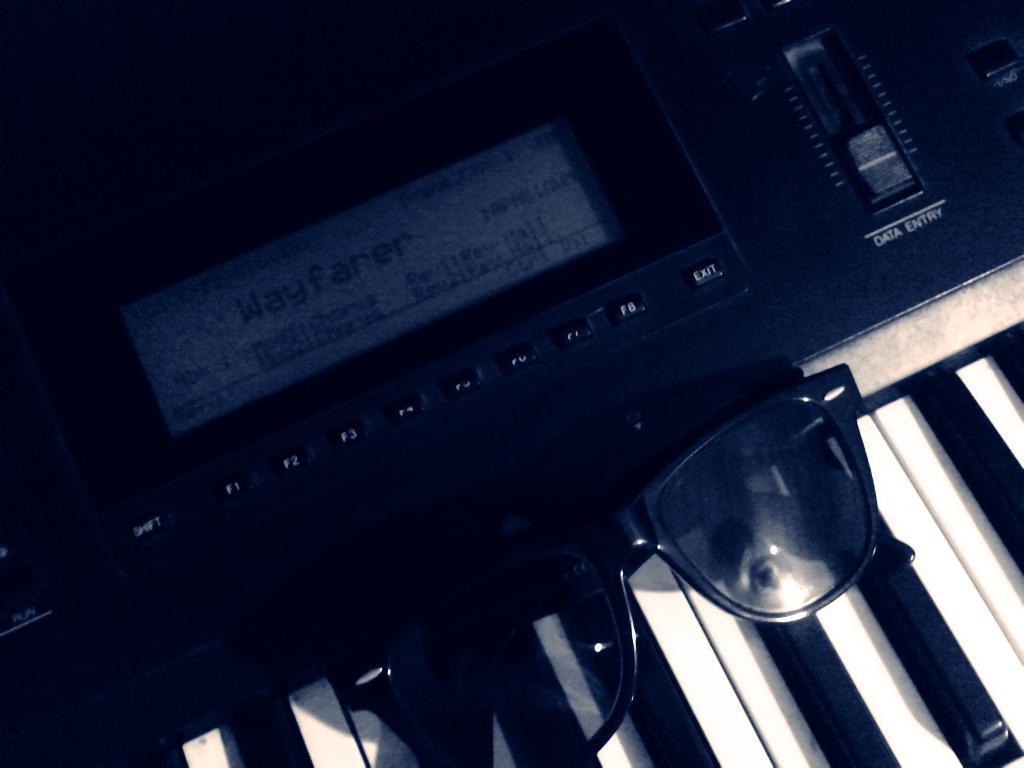Describe this image in one or two sentences. In this picture we can see a piano and goggles in black colour. 